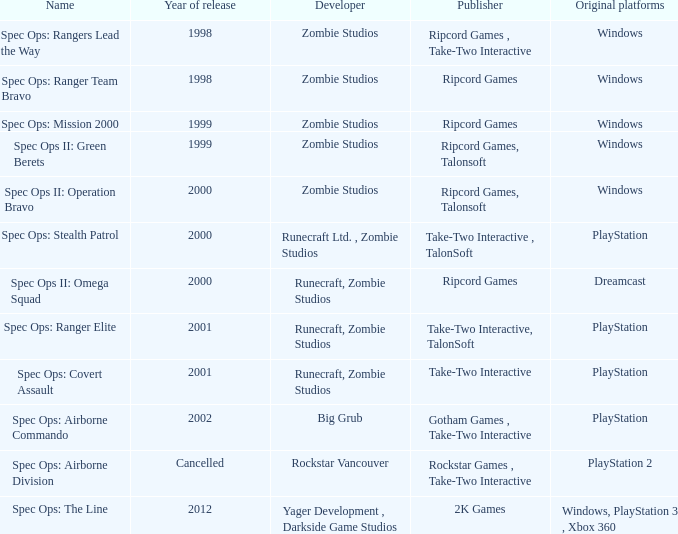Which developer has a year of cancelled releases? Rockstar Vancouver. 